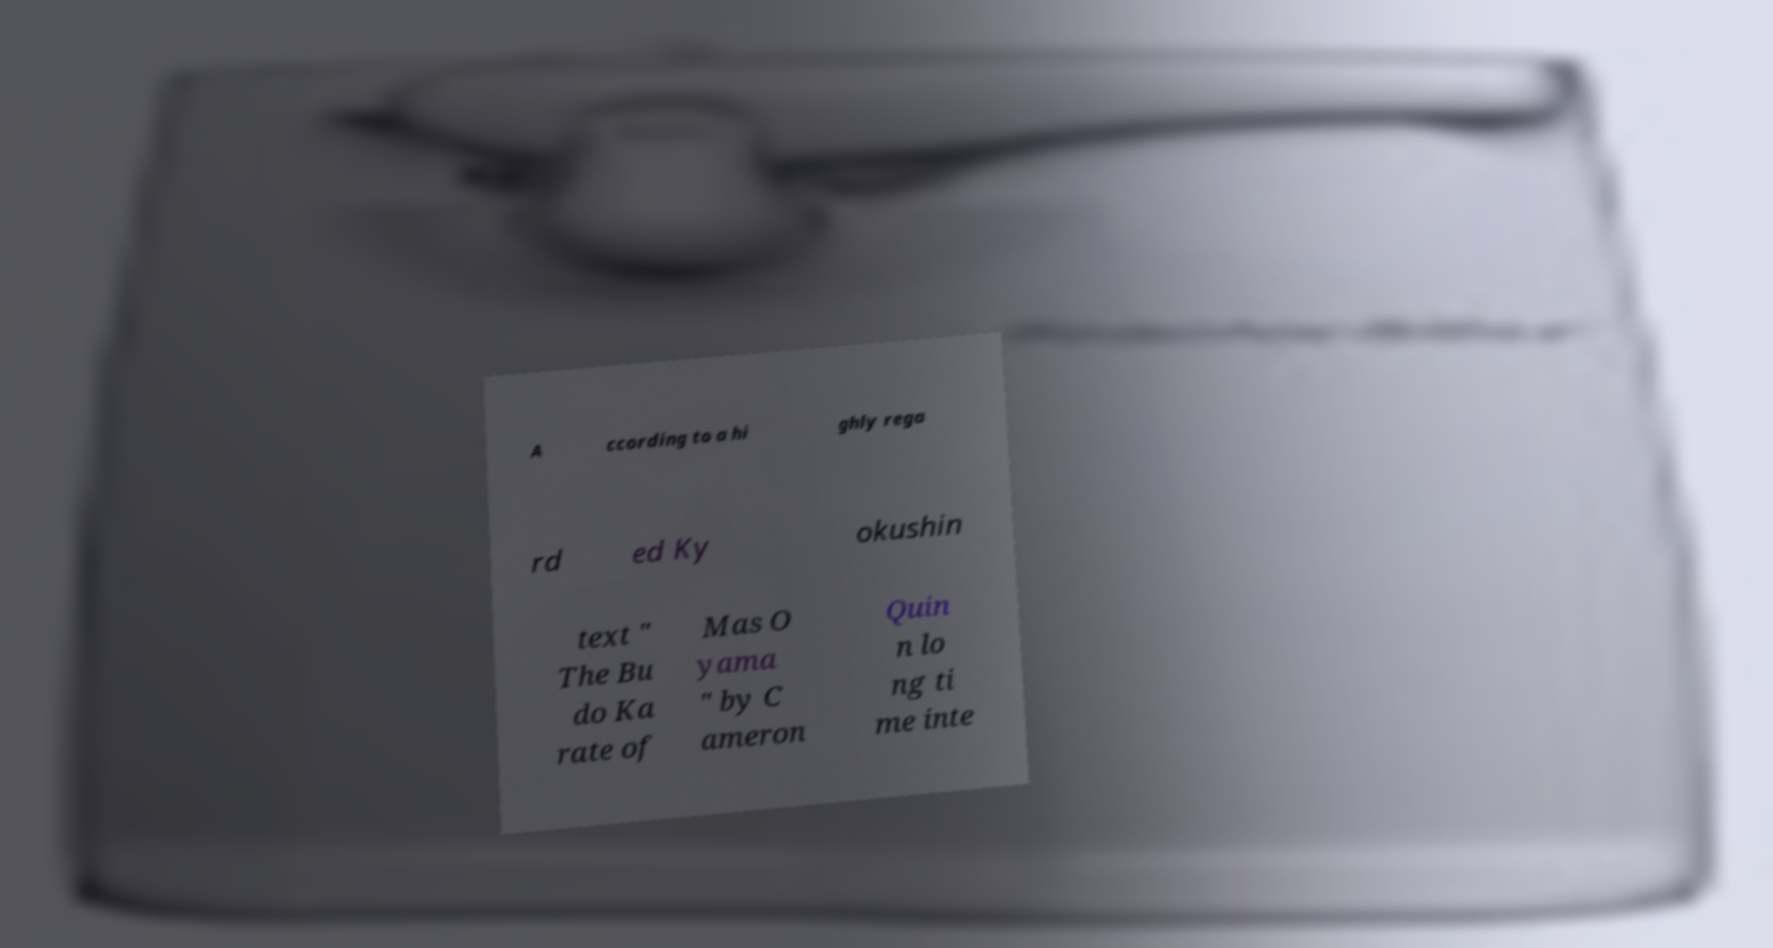Can you accurately transcribe the text from the provided image for me? A ccording to a hi ghly rega rd ed Ky okushin text " The Bu do Ka rate of Mas O yama " by C ameron Quin n lo ng ti me inte 